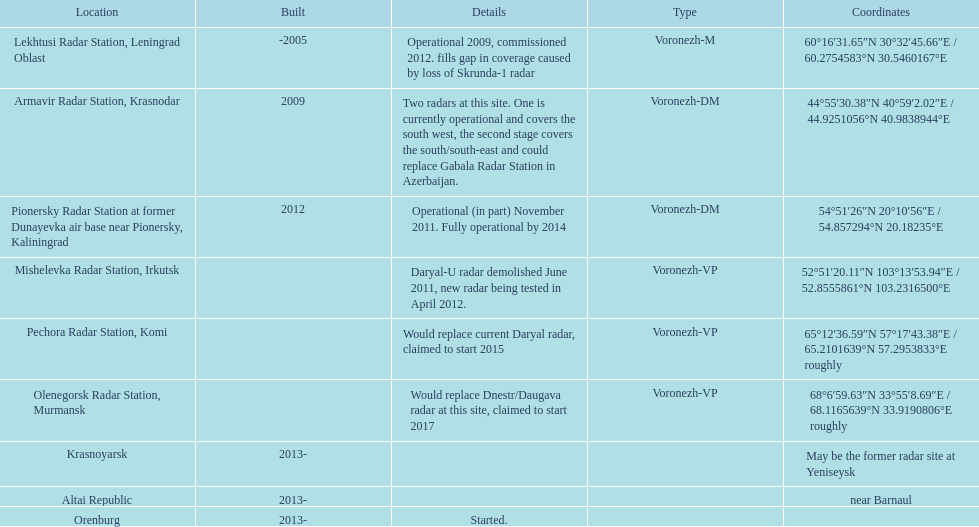How many voronezh radars were established before 2010? 2. Parse the table in full. {'header': ['Location', 'Built', 'Details', 'Type', 'Coordinates'], 'rows': [['Lekhtusi Radar Station, Leningrad Oblast', '-2005', 'Operational 2009, commissioned 2012. fills gap in coverage caused by loss of Skrunda-1 radar', 'Voronezh-M', '60°16′31.65″N 30°32′45.66″E\ufeff / \ufeff60.2754583°N 30.5460167°E'], ['Armavir Radar Station, Krasnodar', '2009', 'Two radars at this site. One is currently operational and covers the south west, the second stage covers the south/south-east and could replace Gabala Radar Station in Azerbaijan.', 'Voronezh-DM', '44°55′30.38″N 40°59′2.02″E\ufeff / \ufeff44.9251056°N 40.9838944°E'], ['Pionersky Radar Station at former Dunayevka air base near Pionersky, Kaliningrad', '2012', 'Operational (in part) November 2011. Fully operational by 2014', 'Voronezh-DM', '54°51′26″N 20°10′56″E\ufeff / \ufeff54.857294°N 20.18235°E'], ['Mishelevka Radar Station, Irkutsk', '', 'Daryal-U radar demolished June 2011, new radar being tested in April 2012.', 'Voronezh-VP', '52°51′20.11″N 103°13′53.94″E\ufeff / \ufeff52.8555861°N 103.2316500°E'], ['Pechora Radar Station, Komi', '', 'Would replace current Daryal radar, claimed to start 2015', 'Voronezh-VP', '65°12′36.59″N 57°17′43.38″E\ufeff / \ufeff65.2101639°N 57.2953833°E roughly'], ['Olenegorsk Radar Station, Murmansk', '', 'Would replace Dnestr/Daugava radar at this site, claimed to start 2017', 'Voronezh-VP', '68°6′59.63″N 33°55′8.69″E\ufeff / \ufeff68.1165639°N 33.9190806°E roughly'], ['Krasnoyarsk', '2013-', '', '', 'May be the former radar site at Yeniseysk'], ['Altai Republic', '2013-', '', '', 'near Barnaul'], ['Orenburg', '2013-', 'Started.', '', '']]} 